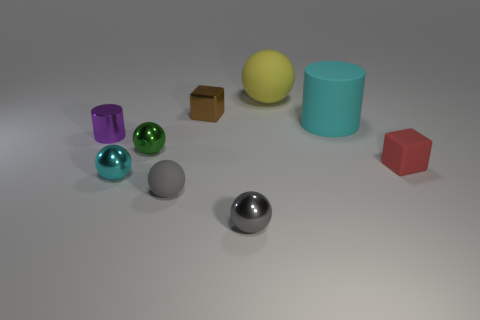Are there the same number of tiny cylinders to the left of the purple cylinder and spheres to the left of the small matte ball?
Your response must be concise. No. Does the small shiny thing on the right side of the tiny brown shiny thing have the same color as the matte thing to the left of the small gray metallic object?
Your answer should be very brief. Yes. Is the number of tiny gray matte objects behind the yellow rubber thing greater than the number of small green shiny balls?
Offer a terse response. No. There is a red thing that is the same material as the large cylinder; what shape is it?
Provide a short and direct response. Cube. There is a red object that is in front of the purple cylinder; is its size the same as the green metal object?
Make the answer very short. Yes. There is a large matte object in front of the small metallic thing behind the purple shiny thing; what shape is it?
Give a very brief answer. Cylinder. There is a cyan shiny thing that is in front of the tiny metal object behind the big cyan cylinder; what size is it?
Provide a short and direct response. Small. The tiny block to the right of the large yellow ball is what color?
Provide a succinct answer. Red. What is the size of the yellow object that is the same material as the large cyan cylinder?
Your answer should be very brief. Large. How many red things are the same shape as the tiny cyan thing?
Your answer should be very brief. 0. 